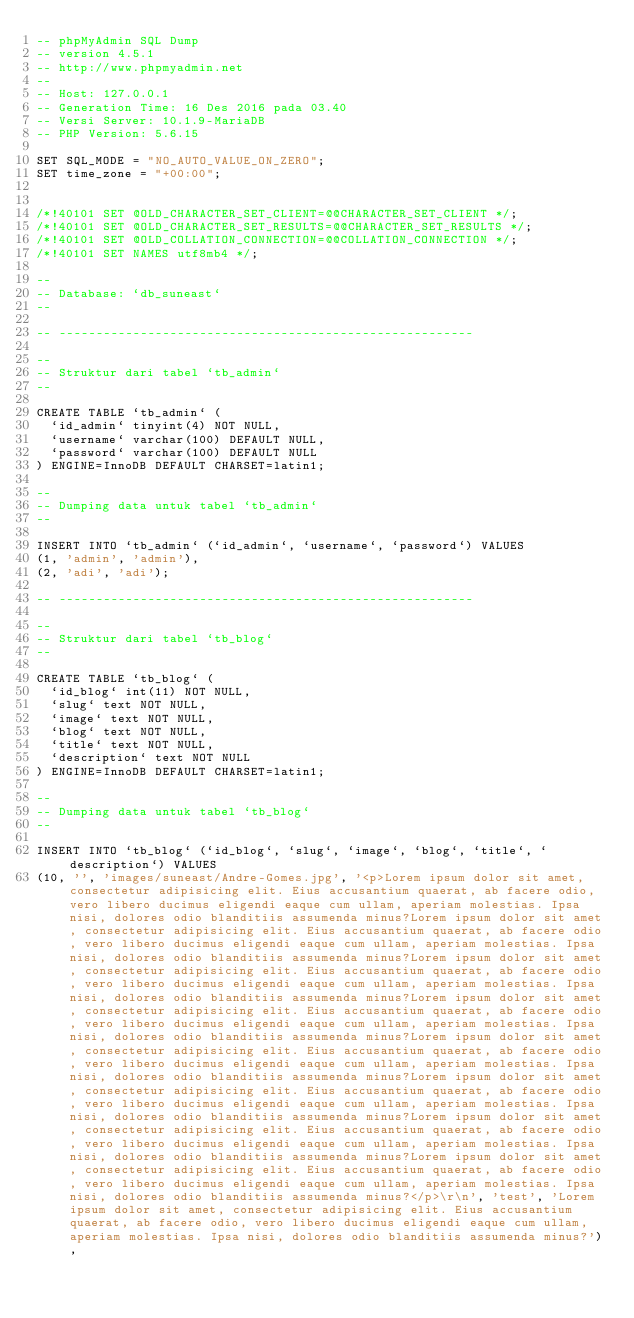Convert code to text. <code><loc_0><loc_0><loc_500><loc_500><_SQL_>-- phpMyAdmin SQL Dump
-- version 4.5.1
-- http://www.phpmyadmin.net
--
-- Host: 127.0.0.1
-- Generation Time: 16 Des 2016 pada 03.40
-- Versi Server: 10.1.9-MariaDB
-- PHP Version: 5.6.15

SET SQL_MODE = "NO_AUTO_VALUE_ON_ZERO";
SET time_zone = "+00:00";


/*!40101 SET @OLD_CHARACTER_SET_CLIENT=@@CHARACTER_SET_CLIENT */;
/*!40101 SET @OLD_CHARACTER_SET_RESULTS=@@CHARACTER_SET_RESULTS */;
/*!40101 SET @OLD_COLLATION_CONNECTION=@@COLLATION_CONNECTION */;
/*!40101 SET NAMES utf8mb4 */;

--
-- Database: `db_suneast`
--

-- --------------------------------------------------------

--
-- Struktur dari tabel `tb_admin`
--

CREATE TABLE `tb_admin` (
  `id_admin` tinyint(4) NOT NULL,
  `username` varchar(100) DEFAULT NULL,
  `password` varchar(100) DEFAULT NULL
) ENGINE=InnoDB DEFAULT CHARSET=latin1;

--
-- Dumping data untuk tabel `tb_admin`
--

INSERT INTO `tb_admin` (`id_admin`, `username`, `password`) VALUES
(1, 'admin', 'admin'),
(2, 'adi', 'adi');

-- --------------------------------------------------------

--
-- Struktur dari tabel `tb_blog`
--

CREATE TABLE `tb_blog` (
  `id_blog` int(11) NOT NULL,
  `slug` text NOT NULL,
  `image` text NOT NULL,
  `blog` text NOT NULL,
  `title` text NOT NULL,
  `description` text NOT NULL
) ENGINE=InnoDB DEFAULT CHARSET=latin1;

--
-- Dumping data untuk tabel `tb_blog`
--

INSERT INTO `tb_blog` (`id_blog`, `slug`, `image`, `blog`, `title`, `description`) VALUES
(10, '', 'images/suneast/Andre-Gomes.jpg', '<p>Lorem ipsum dolor sit amet, consectetur adipisicing elit. Eius accusantium quaerat, ab facere odio, vero libero ducimus eligendi eaque cum ullam, aperiam molestias. Ipsa nisi, dolores odio blanditiis assumenda minus?Lorem ipsum dolor sit amet, consectetur adipisicing elit. Eius accusantium quaerat, ab facere odio, vero libero ducimus eligendi eaque cum ullam, aperiam molestias. Ipsa nisi, dolores odio blanditiis assumenda minus?Lorem ipsum dolor sit amet, consectetur adipisicing elit. Eius accusantium quaerat, ab facere odio, vero libero ducimus eligendi eaque cum ullam, aperiam molestias. Ipsa nisi, dolores odio blanditiis assumenda minus?Lorem ipsum dolor sit amet, consectetur adipisicing elit. Eius accusantium quaerat, ab facere odio, vero libero ducimus eligendi eaque cum ullam, aperiam molestias. Ipsa nisi, dolores odio blanditiis assumenda minus?Lorem ipsum dolor sit amet, consectetur adipisicing elit. Eius accusantium quaerat, ab facere odio, vero libero ducimus eligendi eaque cum ullam, aperiam molestias. Ipsa nisi, dolores odio blanditiis assumenda minus?Lorem ipsum dolor sit amet, consectetur adipisicing elit. Eius accusantium quaerat, ab facere odio, vero libero ducimus eligendi eaque cum ullam, aperiam molestias. Ipsa nisi, dolores odio blanditiis assumenda minus?Lorem ipsum dolor sit amet, consectetur adipisicing elit. Eius accusantium quaerat, ab facere odio, vero libero ducimus eligendi eaque cum ullam, aperiam molestias. Ipsa nisi, dolores odio blanditiis assumenda minus?Lorem ipsum dolor sit amet, consectetur adipisicing elit. Eius accusantium quaerat, ab facere odio, vero libero ducimus eligendi eaque cum ullam, aperiam molestias. Ipsa nisi, dolores odio blanditiis assumenda minus?</p>\r\n', 'test', 'Lorem ipsum dolor sit amet, consectetur adipisicing elit. Eius accusantium quaerat, ab facere odio, vero libero ducimus eligendi eaque cum ullam, aperiam molestias. Ipsa nisi, dolores odio blanditiis assumenda minus?'),</code> 